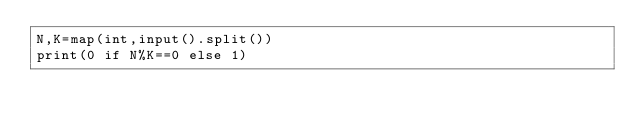Convert code to text. <code><loc_0><loc_0><loc_500><loc_500><_Python_>N,K=map(int,input().split())
print(0 if N%K==0 else 1)</code> 